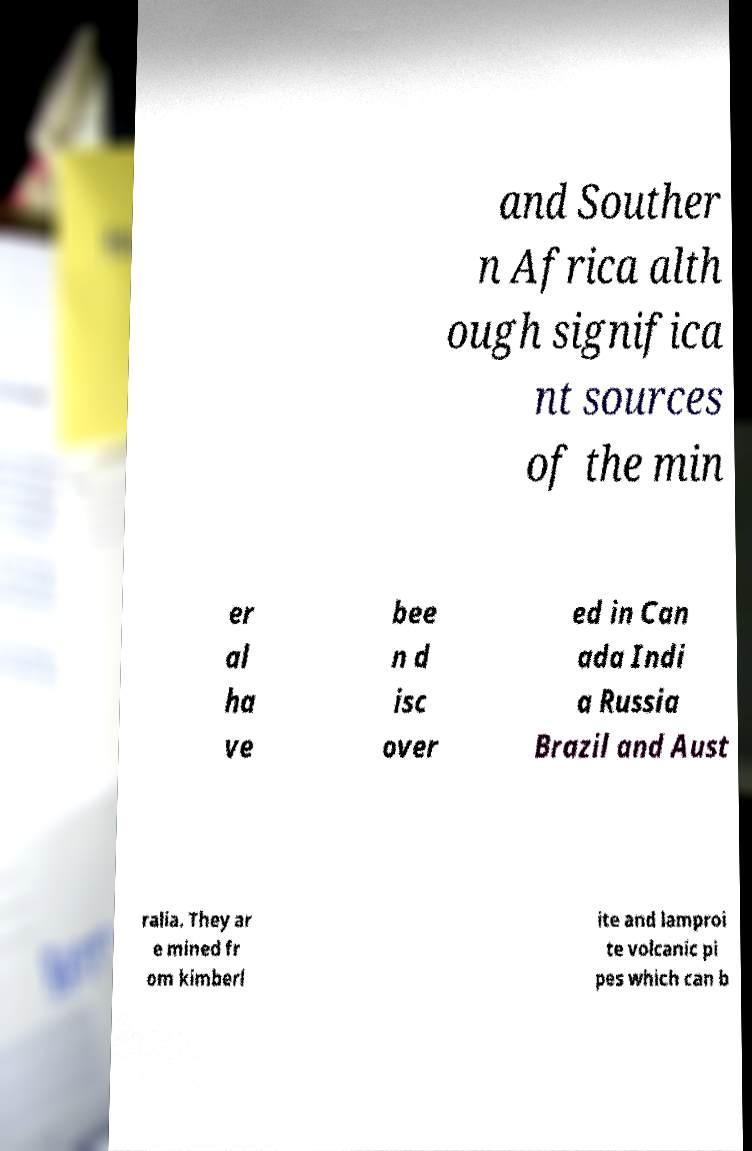For documentation purposes, I need the text within this image transcribed. Could you provide that? and Souther n Africa alth ough significa nt sources of the min er al ha ve bee n d isc over ed in Can ada Indi a Russia Brazil and Aust ralia. They ar e mined fr om kimberl ite and lamproi te volcanic pi pes which can b 